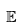<formula> <loc_0><loc_0><loc_500><loc_500>\mathbb { E }</formula> 